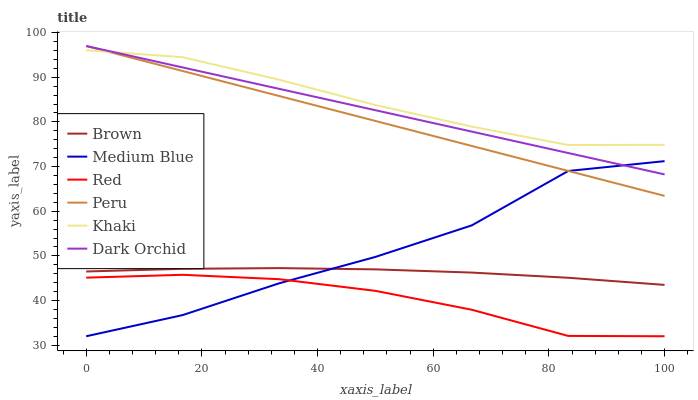Does Red have the minimum area under the curve?
Answer yes or no. Yes. Does Khaki have the maximum area under the curve?
Answer yes or no. Yes. Does Medium Blue have the minimum area under the curve?
Answer yes or no. No. Does Medium Blue have the maximum area under the curve?
Answer yes or no. No. Is Dark Orchid the smoothest?
Answer yes or no. Yes. Is Medium Blue the roughest?
Answer yes or no. Yes. Is Khaki the smoothest?
Answer yes or no. No. Is Khaki the roughest?
Answer yes or no. No. Does Medium Blue have the lowest value?
Answer yes or no. Yes. Does Khaki have the lowest value?
Answer yes or no. No. Does Peru have the highest value?
Answer yes or no. Yes. Does Khaki have the highest value?
Answer yes or no. No. Is Brown less than Peru?
Answer yes or no. Yes. Is Khaki greater than Brown?
Answer yes or no. Yes. Does Dark Orchid intersect Medium Blue?
Answer yes or no. Yes. Is Dark Orchid less than Medium Blue?
Answer yes or no. No. Is Dark Orchid greater than Medium Blue?
Answer yes or no. No. Does Brown intersect Peru?
Answer yes or no. No. 